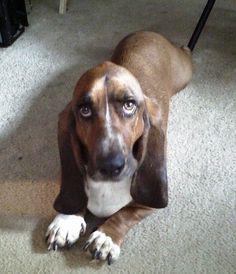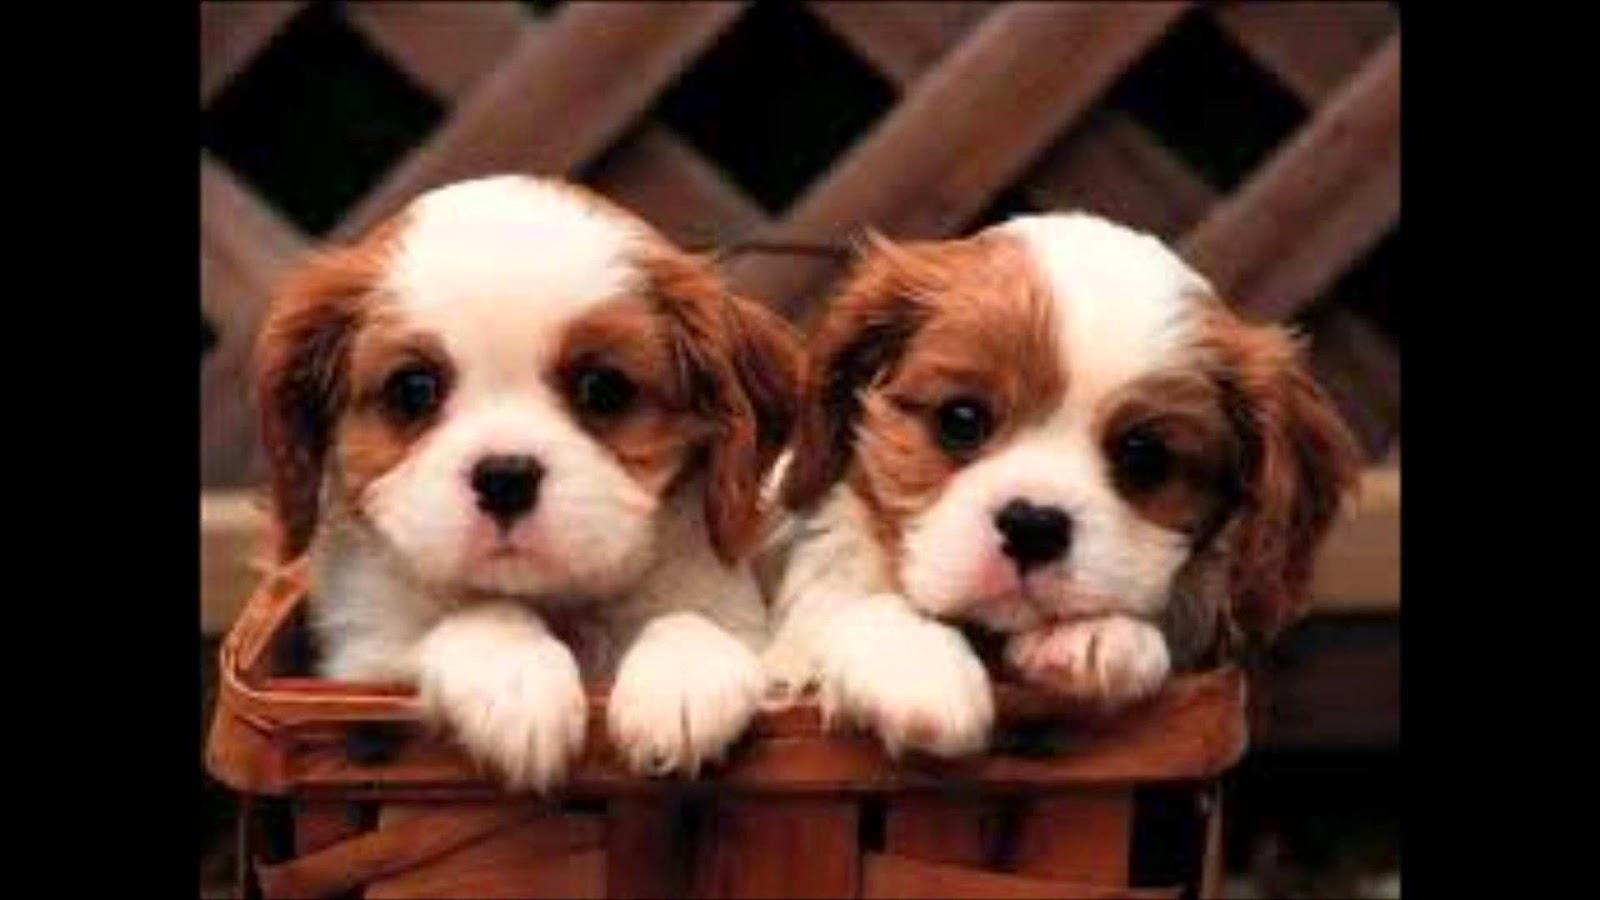The first image is the image on the left, the second image is the image on the right. Analyze the images presented: Is the assertion "There is at least two dogs in the right image." valid? Answer yes or no. Yes. 